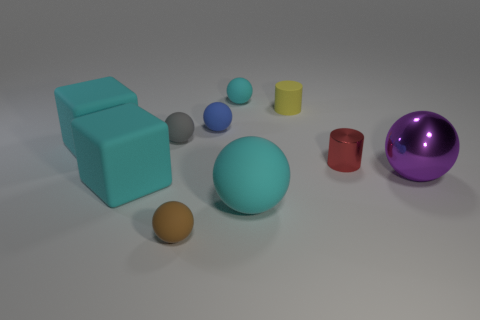Is the material of the blue thing the same as the big cyan object to the right of the small brown rubber thing?
Ensure brevity in your answer.  Yes. What number of small balls have the same material as the blue object?
Provide a short and direct response. 3. What shape is the large cyan thing that is to the right of the small cyan rubber thing?
Offer a very short reply. Sphere. Are the small thing that is behind the tiny yellow object and the small cylinder behind the gray matte sphere made of the same material?
Provide a short and direct response. Yes. Is there a small green object of the same shape as the tiny cyan matte thing?
Provide a short and direct response. No. What number of objects are cyan objects behind the yellow matte cylinder or tiny purple metallic cylinders?
Provide a succinct answer. 1. Is the number of blocks left of the small blue rubber object greater than the number of cubes that are on the right side of the small cyan thing?
Your answer should be compact. Yes. What number of matte things are either green objects or purple spheres?
Ensure brevity in your answer.  0. There is a small ball that is the same color as the large matte sphere; what is its material?
Your answer should be very brief. Rubber. Are there fewer tiny yellow matte cylinders that are in front of the large shiny ball than yellow matte things on the right side of the tiny matte cylinder?
Your response must be concise. No. 